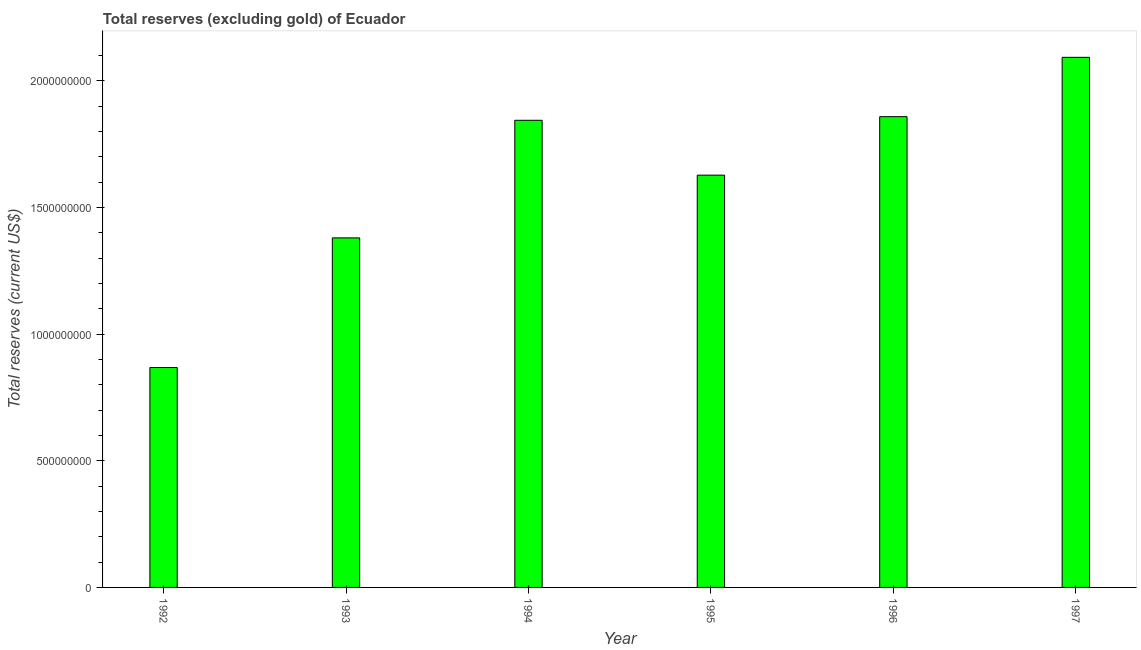Does the graph contain any zero values?
Your response must be concise. No. Does the graph contain grids?
Provide a succinct answer. No. What is the title of the graph?
Your response must be concise. Total reserves (excluding gold) of Ecuador. What is the label or title of the X-axis?
Your response must be concise. Year. What is the label or title of the Y-axis?
Provide a short and direct response. Total reserves (current US$). What is the total reserves (excluding gold) in 1993?
Offer a very short reply. 1.38e+09. Across all years, what is the maximum total reserves (excluding gold)?
Offer a very short reply. 2.09e+09. Across all years, what is the minimum total reserves (excluding gold)?
Keep it short and to the point. 8.68e+08. In which year was the total reserves (excluding gold) minimum?
Provide a short and direct response. 1992. What is the sum of the total reserves (excluding gold)?
Provide a short and direct response. 9.67e+09. What is the difference between the total reserves (excluding gold) in 1995 and 1996?
Make the answer very short. -2.31e+08. What is the average total reserves (excluding gold) per year?
Ensure brevity in your answer.  1.61e+09. What is the median total reserves (excluding gold)?
Provide a succinct answer. 1.74e+09. Do a majority of the years between 1992 and 1996 (inclusive) have total reserves (excluding gold) greater than 200000000 US$?
Give a very brief answer. Yes. What is the ratio of the total reserves (excluding gold) in 1993 to that in 1995?
Offer a terse response. 0.85. What is the difference between the highest and the second highest total reserves (excluding gold)?
Your answer should be very brief. 2.34e+08. What is the difference between the highest and the lowest total reserves (excluding gold)?
Make the answer very short. 1.22e+09. In how many years, is the total reserves (excluding gold) greater than the average total reserves (excluding gold) taken over all years?
Ensure brevity in your answer.  4. How many bars are there?
Your answer should be very brief. 6. What is the difference between two consecutive major ticks on the Y-axis?
Offer a terse response. 5.00e+08. What is the Total reserves (current US$) in 1992?
Your answer should be compact. 8.68e+08. What is the Total reserves (current US$) in 1993?
Offer a very short reply. 1.38e+09. What is the Total reserves (current US$) in 1994?
Ensure brevity in your answer.  1.84e+09. What is the Total reserves (current US$) of 1995?
Give a very brief answer. 1.63e+09. What is the Total reserves (current US$) in 1996?
Provide a short and direct response. 1.86e+09. What is the Total reserves (current US$) of 1997?
Make the answer very short. 2.09e+09. What is the difference between the Total reserves (current US$) in 1992 and 1993?
Your answer should be compact. -5.12e+08. What is the difference between the Total reserves (current US$) in 1992 and 1994?
Provide a succinct answer. -9.76e+08. What is the difference between the Total reserves (current US$) in 1992 and 1995?
Your answer should be compact. -7.59e+08. What is the difference between the Total reserves (current US$) in 1992 and 1996?
Provide a short and direct response. -9.90e+08. What is the difference between the Total reserves (current US$) in 1992 and 1997?
Ensure brevity in your answer.  -1.22e+09. What is the difference between the Total reserves (current US$) in 1993 and 1994?
Make the answer very short. -4.64e+08. What is the difference between the Total reserves (current US$) in 1993 and 1995?
Make the answer very short. -2.48e+08. What is the difference between the Total reserves (current US$) in 1993 and 1996?
Keep it short and to the point. -4.79e+08. What is the difference between the Total reserves (current US$) in 1993 and 1997?
Your answer should be compact. -7.13e+08. What is the difference between the Total reserves (current US$) in 1994 and 1995?
Offer a very short reply. 2.17e+08. What is the difference between the Total reserves (current US$) in 1994 and 1996?
Your answer should be very brief. -1.42e+07. What is the difference between the Total reserves (current US$) in 1994 and 1997?
Ensure brevity in your answer.  -2.49e+08. What is the difference between the Total reserves (current US$) in 1995 and 1996?
Offer a terse response. -2.31e+08. What is the difference between the Total reserves (current US$) in 1995 and 1997?
Offer a very short reply. -4.65e+08. What is the difference between the Total reserves (current US$) in 1996 and 1997?
Offer a terse response. -2.34e+08. What is the ratio of the Total reserves (current US$) in 1992 to that in 1993?
Your response must be concise. 0.63. What is the ratio of the Total reserves (current US$) in 1992 to that in 1994?
Your answer should be very brief. 0.47. What is the ratio of the Total reserves (current US$) in 1992 to that in 1995?
Provide a short and direct response. 0.53. What is the ratio of the Total reserves (current US$) in 1992 to that in 1996?
Provide a succinct answer. 0.47. What is the ratio of the Total reserves (current US$) in 1992 to that in 1997?
Provide a short and direct response. 0.41. What is the ratio of the Total reserves (current US$) in 1993 to that in 1994?
Your answer should be compact. 0.75. What is the ratio of the Total reserves (current US$) in 1993 to that in 1995?
Offer a terse response. 0.85. What is the ratio of the Total reserves (current US$) in 1993 to that in 1996?
Provide a succinct answer. 0.74. What is the ratio of the Total reserves (current US$) in 1993 to that in 1997?
Ensure brevity in your answer.  0.66. What is the ratio of the Total reserves (current US$) in 1994 to that in 1995?
Your answer should be very brief. 1.13. What is the ratio of the Total reserves (current US$) in 1994 to that in 1997?
Provide a succinct answer. 0.88. What is the ratio of the Total reserves (current US$) in 1995 to that in 1996?
Provide a succinct answer. 0.88. What is the ratio of the Total reserves (current US$) in 1995 to that in 1997?
Keep it short and to the point. 0.78. What is the ratio of the Total reserves (current US$) in 1996 to that in 1997?
Offer a very short reply. 0.89. 